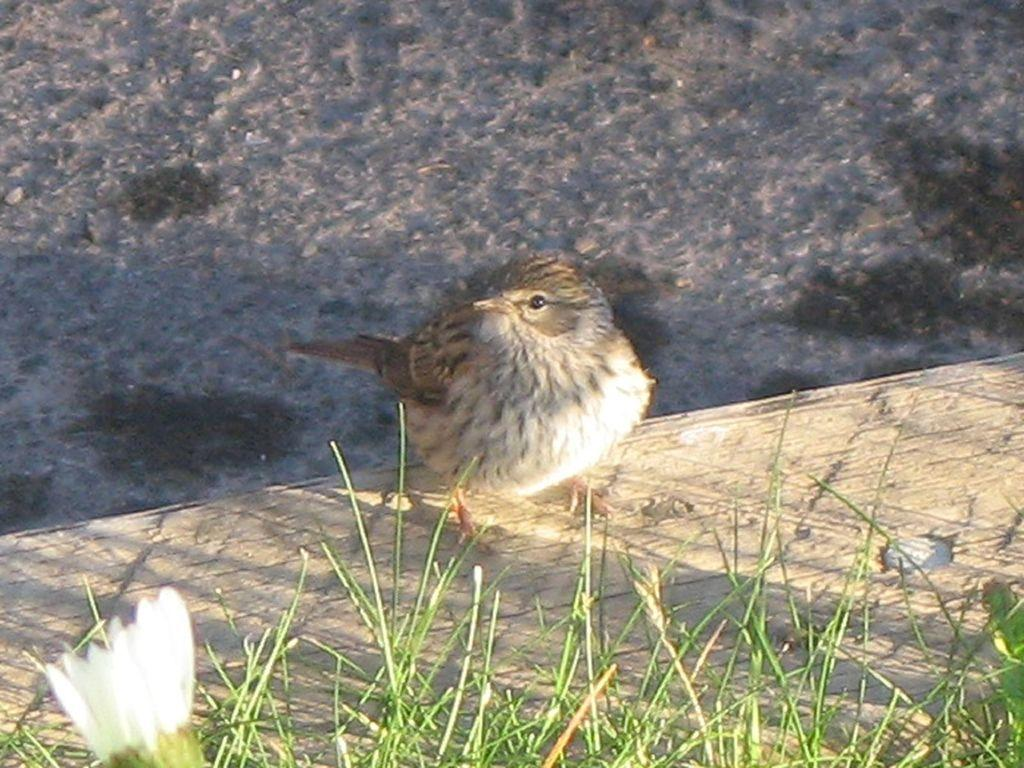What is the main subject in the center of the image? There is a small bird in the center of the image. What can be seen in the bottom left side of the image? There is a flower in the bottom left side of the image. What type of vegetation is present at the bottom side of the image? There is grass at the bottom side of the image. What type of machine can be seen in the image? There is no machine present in the image; it features a small bird, a flower, and grass. What type of wine is being served in the image? There is no wine present in the image. 